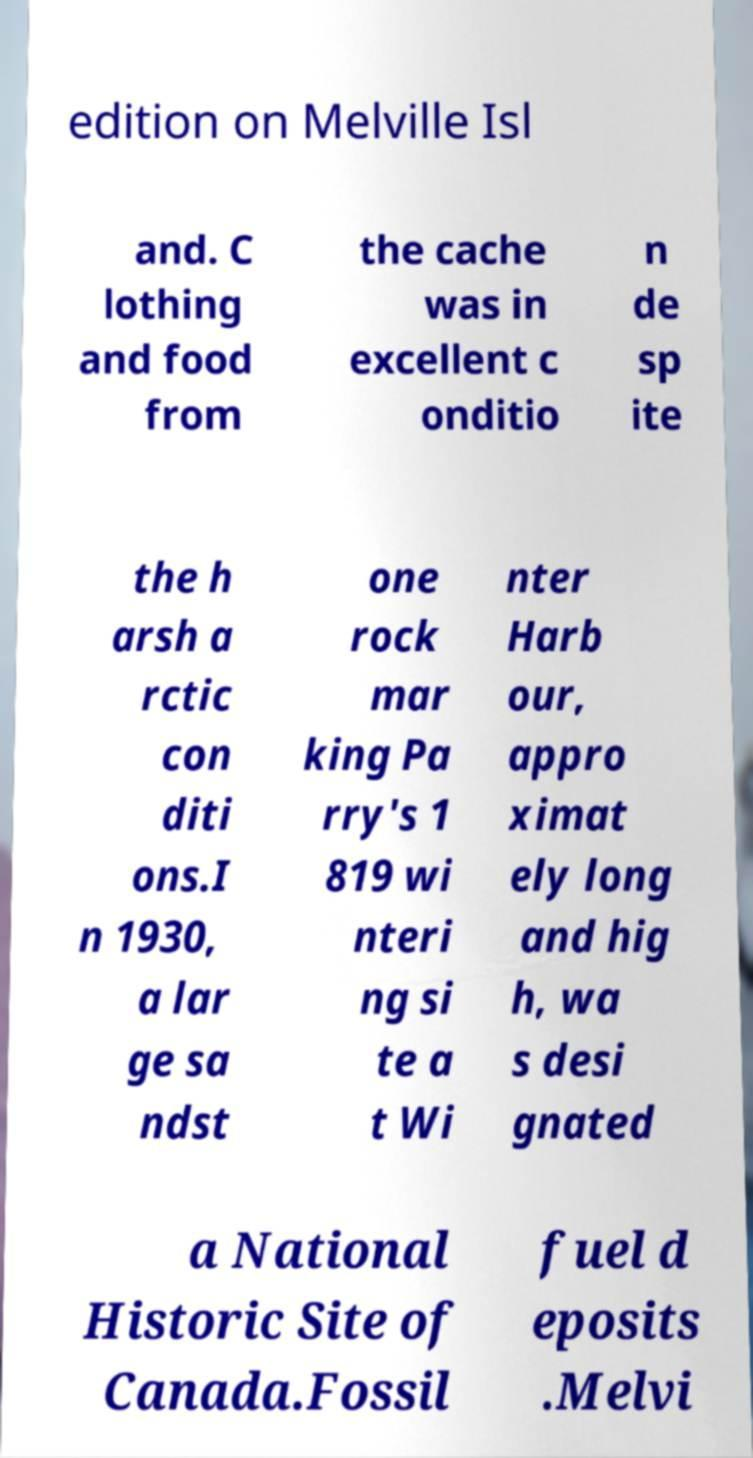There's text embedded in this image that I need extracted. Can you transcribe it verbatim? edition on Melville Isl and. C lothing and food from the cache was in excellent c onditio n de sp ite the h arsh a rctic con diti ons.I n 1930, a lar ge sa ndst one rock mar king Pa rry's 1 819 wi nteri ng si te a t Wi nter Harb our, appro ximat ely long and hig h, wa s desi gnated a National Historic Site of Canada.Fossil fuel d eposits .Melvi 